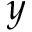<formula> <loc_0><loc_0><loc_500><loc_500>y</formula> 